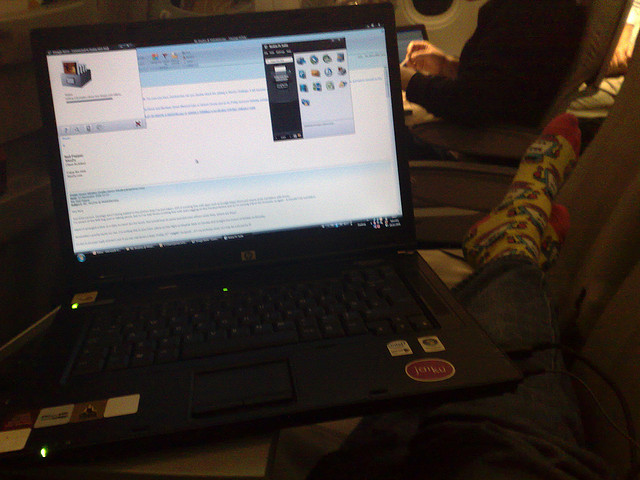Can you comment on the lighting and camera quality based on the image? The image appears to be taken in a low-light setting with ambient light primarily illuminating the scene from the side, which hints at an indoor environment with soft lighting. The camera quality seems modest, as evidenced by the slightly grainy texture, low contrast, and limited dynamic range, which fails to capture the details sharply. 